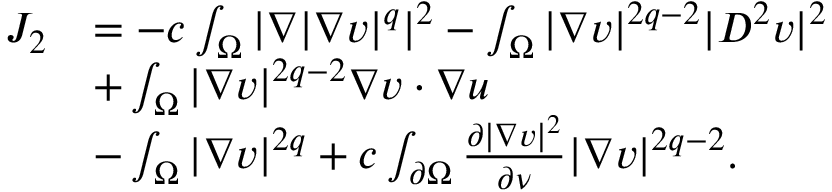Convert formula to latex. <formula><loc_0><loc_0><loc_500><loc_500>\begin{array} { r l } { J _ { 2 } } & { = - c \int _ { \Omega } | \nabla | \nabla v | ^ { q } | ^ { 2 } - \int _ { \Omega } | \nabla v | ^ { 2 q - 2 } | D ^ { 2 } v | ^ { 2 } } \\ & { + \int _ { \Omega } | \nabla v | ^ { 2 q - 2 } \nabla v \cdot \nabla u } \\ & { - \int _ { \Omega } | \nabla v | ^ { 2 q } + c \int _ { \partial \Omega } \frac { \partial | \nabla v | ^ { 2 } } { \partial \nu } | \nabla v | ^ { 2 q - 2 } . } \end{array}</formula> 